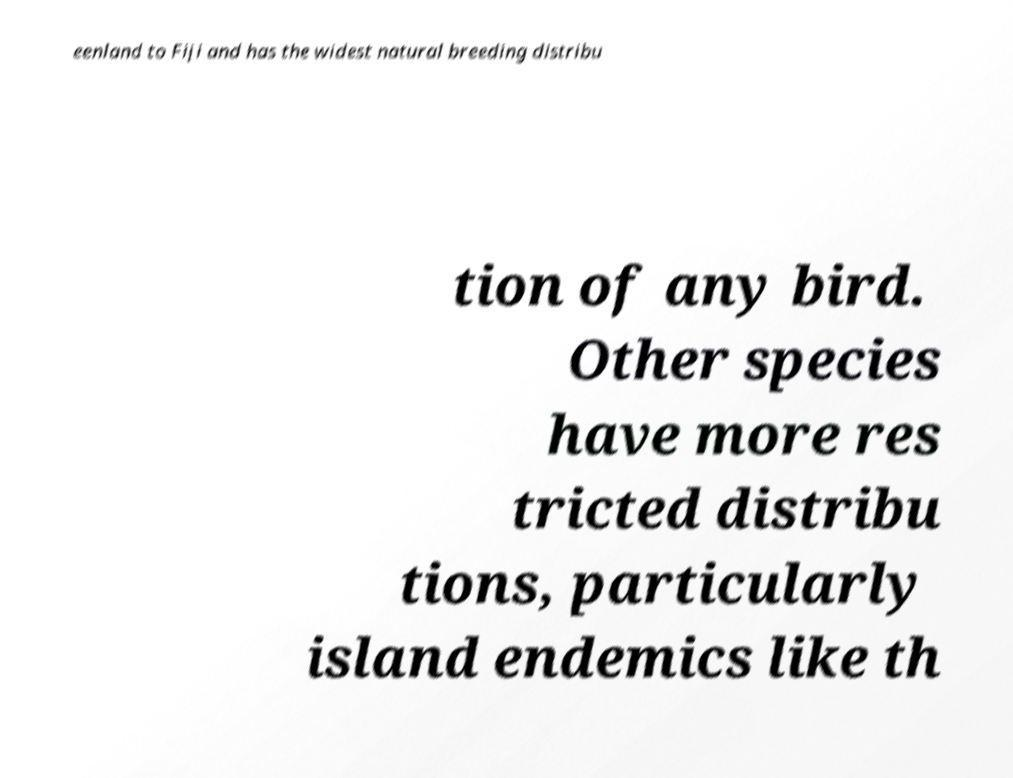I need the written content from this picture converted into text. Can you do that? eenland to Fiji and has the widest natural breeding distribu tion of any bird. Other species have more res tricted distribu tions, particularly island endemics like th 